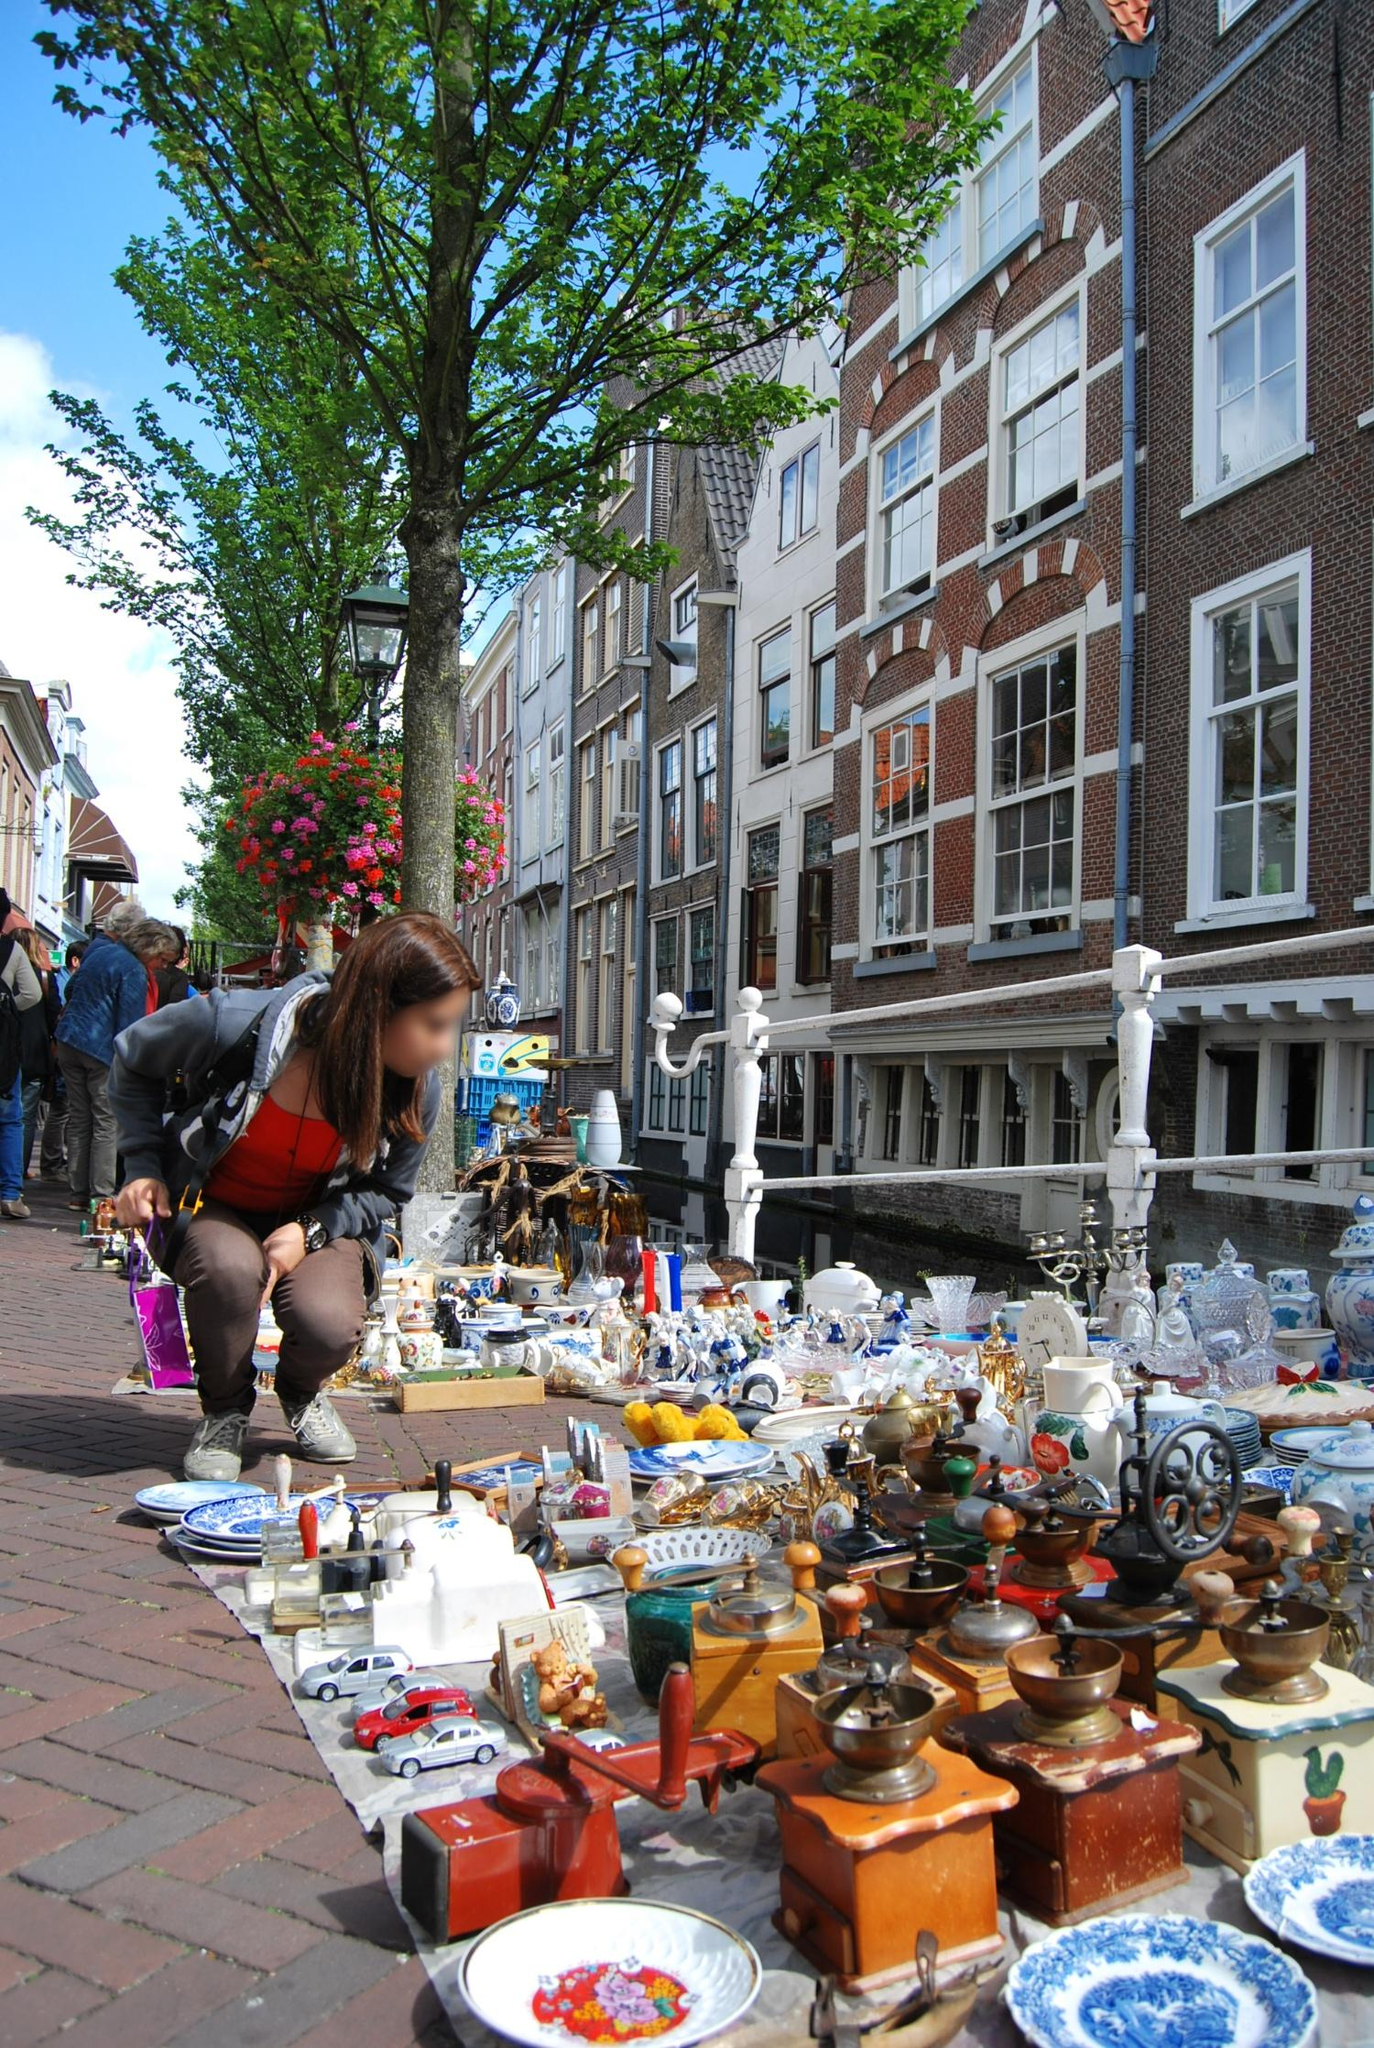Imagine one of the antique items on the market stall has a magical history. What is its story? Among the array of trinkets on the market stall lies an intricately designed coffee grinder, seemingly ordinary at first glance. However, legend has it that this coffee grinder once belonged to a mysterious alchemist from the 16th century. Enchanted by the alchemist, the coffee grinder possesses the ability to transform regular coffee beans into a magical brew that grants the drinker incredible insight and wisdom for a single day.

The alchemist used this magical brew to foresee events and navigate through volatile times, making powerful predictions that altered the course of history. Over the centuries, the coffee grinder changed hands, each owner keeping it a secret to harness its extraordinary powers for their personal pursuits. It's said that the grinder only reveals its magic to those with a pure heart and a genuine quest for knowledge. Its intricate designs symbolize protection, wisdom, and the eternal pursuit of enlightenment, making it a prized possession among collectors who understand its true value. 